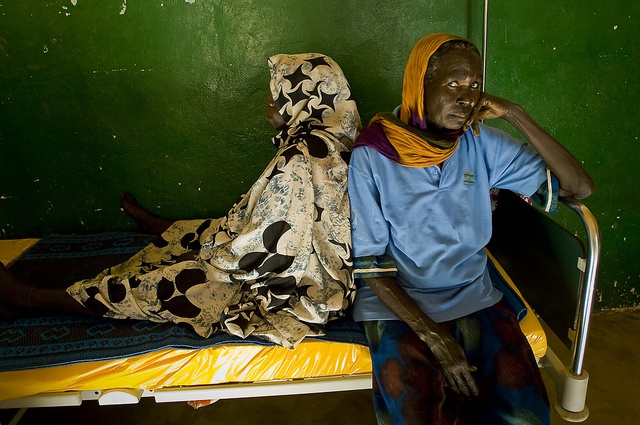Describe the objects in this image and their specific colors. I can see people in darkgreen, black, gray, and maroon tones, bed in darkgreen, black, orange, lightgray, and gold tones, and people in darkgreen, black, tan, and olive tones in this image. 